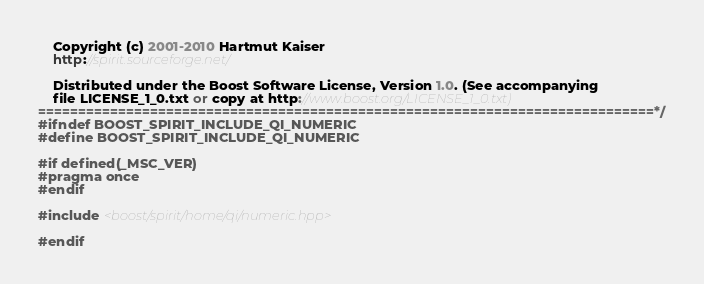Convert code to text. <code><loc_0><loc_0><loc_500><loc_500><_C++_>    Copyright (c) 2001-2010 Hartmut Kaiser
    http://spirit.sourceforge.net/

    Distributed under the Boost Software License, Version 1.0. (See accompanying
    file LICENSE_1_0.txt or copy at http://www.boost.org/LICENSE_1_0.txt)
=============================================================================*/
#ifndef BOOST_SPIRIT_INCLUDE_QI_NUMERIC
#define BOOST_SPIRIT_INCLUDE_QI_NUMERIC

#if defined(_MSC_VER)
#pragma once
#endif

#include <boost/spirit/home/qi/numeric.hpp>

#endif
</code> 